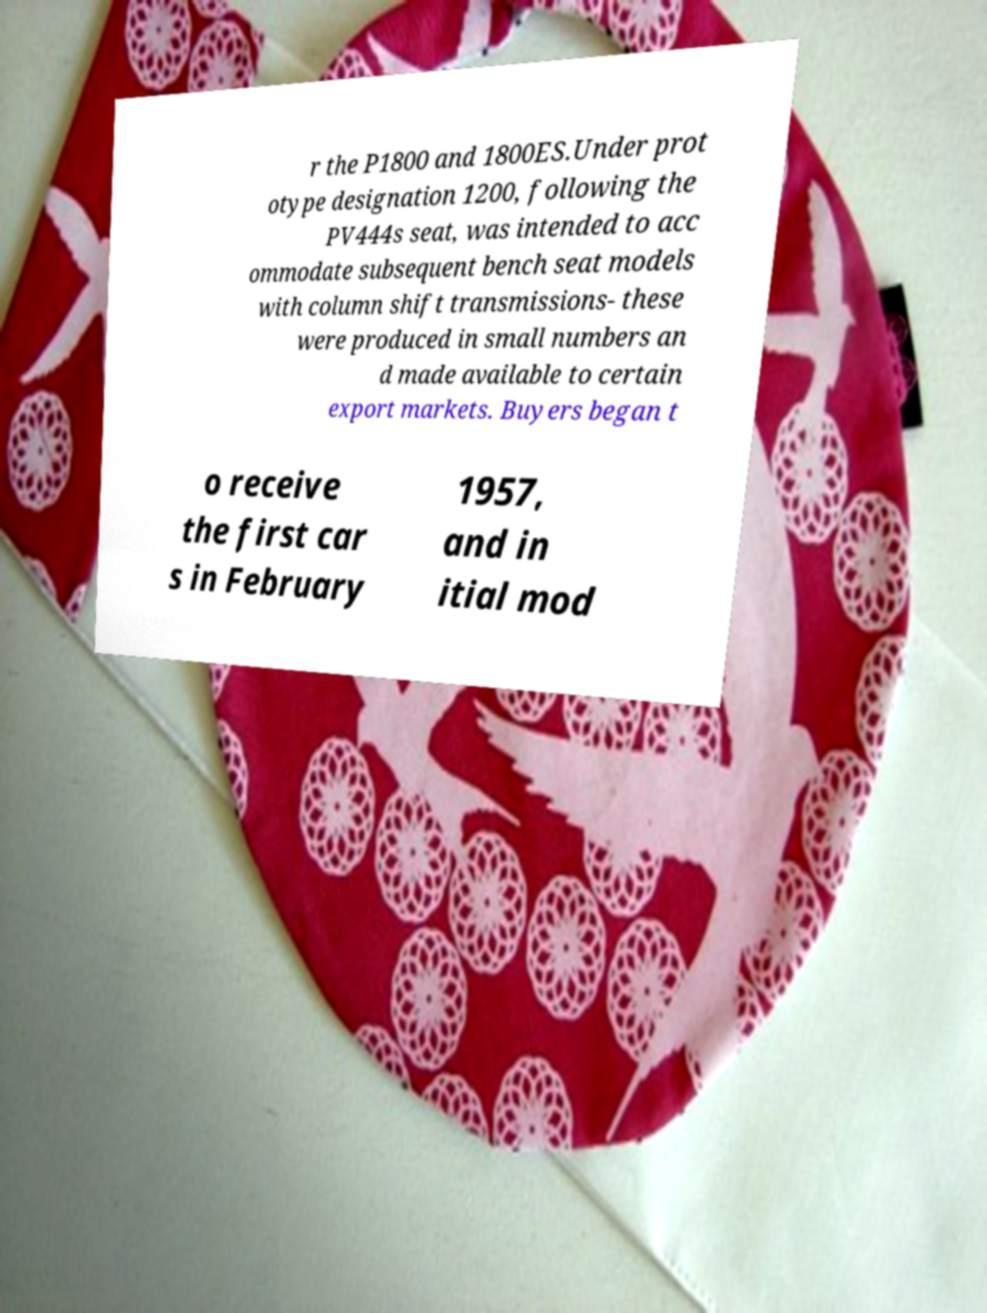Can you read and provide the text displayed in the image?This photo seems to have some interesting text. Can you extract and type it out for me? r the P1800 and 1800ES.Under prot otype designation 1200, following the PV444s seat, was intended to acc ommodate subsequent bench seat models with column shift transmissions- these were produced in small numbers an d made available to certain export markets. Buyers began t o receive the first car s in February 1957, and in itial mod 